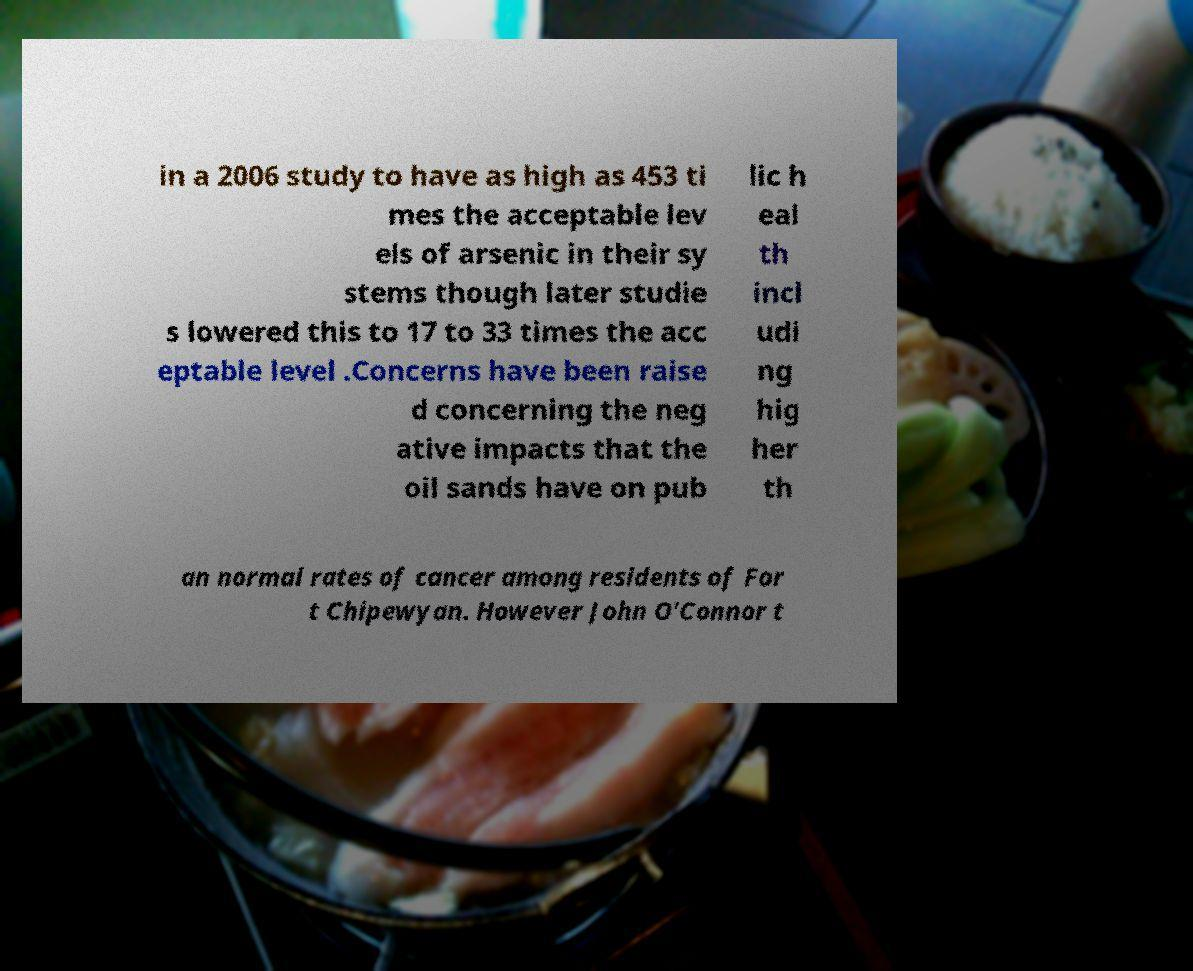What messages or text are displayed in this image? I need them in a readable, typed format. in a 2006 study to have as high as 453 ti mes the acceptable lev els of arsenic in their sy stems though later studie s lowered this to 17 to 33 times the acc eptable level .Concerns have been raise d concerning the neg ative impacts that the oil sands have on pub lic h eal th incl udi ng hig her th an normal rates of cancer among residents of For t Chipewyan. However John O'Connor t 